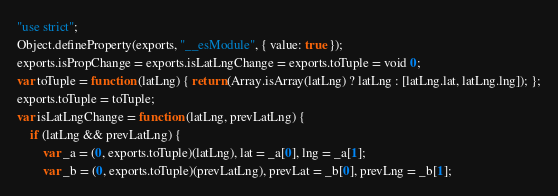<code> <loc_0><loc_0><loc_500><loc_500><_JavaScript_>"use strict";
Object.defineProperty(exports, "__esModule", { value: true });
exports.isPropChange = exports.isLatLngChange = exports.toTuple = void 0;
var toTuple = function (latLng) { return (Array.isArray(latLng) ? latLng : [latLng.lat, latLng.lng]); };
exports.toTuple = toTuple;
var isLatLngChange = function (latLng, prevLatLng) {
    if (latLng && prevLatLng) {
        var _a = (0, exports.toTuple)(latLng), lat = _a[0], lng = _a[1];
        var _b = (0, exports.toTuple)(prevLatLng), prevLat = _b[0], prevLng = _b[1];</code> 